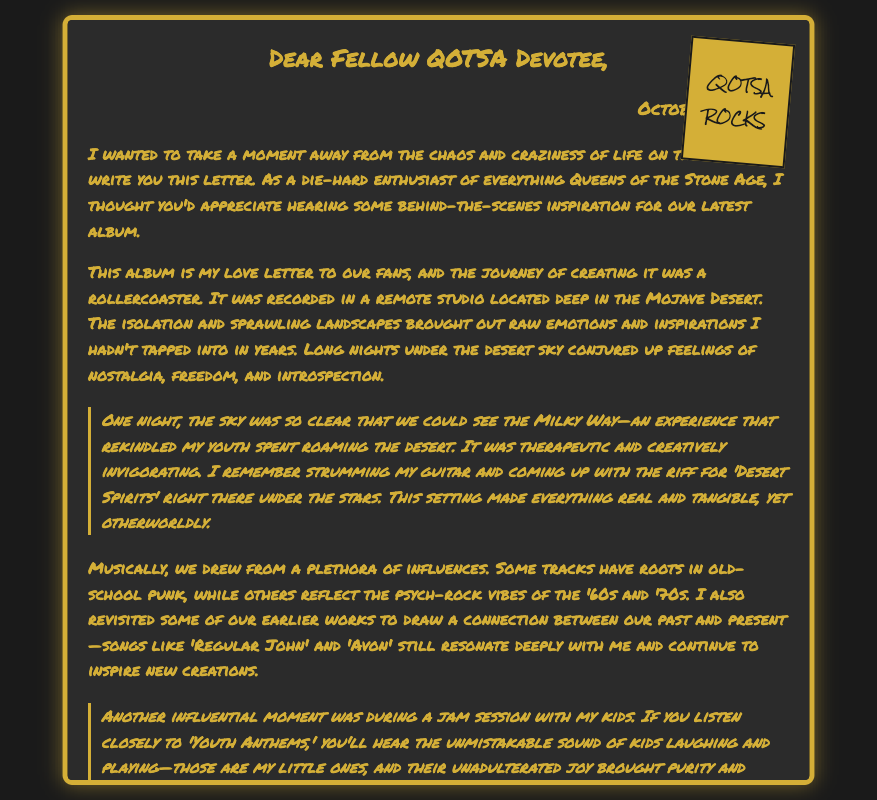What is the date of the letter? The date stated in the letter is October 10, 2023.
Answer: October 10, 2023 Where was the album recorded? The letter mentions that the album was recorded in a remote studio located deep in the Mojave Desert.
Answer: Mojave Desert What is the title of the song inspired by the night under the stars? The letter refers to the song inspired by that experience as 'Desert Spirits'.
Answer: Desert Spirits What does Josh Homme express gratitude for in the letter? He expresses gratitude for the fans and their loyalty and passion.
Answer: Fans' loyalty What sound can be heard in the track 'Youth Anthems'? The letter mentions that kids laughing and playing can be heard in the track.
Answer: Kids laughing How does Josh describe the creative process during the album's production? He describes it as a rollercoaster journey filled with nostalgia, freedom, and introspection.
Answer: Rollercoaster journey What type of influences did the band draw from for the album? The influences mentioned include old-school punk and psych-rock vibes of the '60s and '70s.
Answer: Old-school punk and psych-rock What is described as a therapeutic experience for Josh? He describes the clear night sky in the desert as a therapeutic experience that rekindled his youth.
Answer: Clear night sky What does Josh Homme hope fans find in the album? He hopes fans find meaning and solace in the album similar to what he found while creating it.
Answer: Meaning and solace 